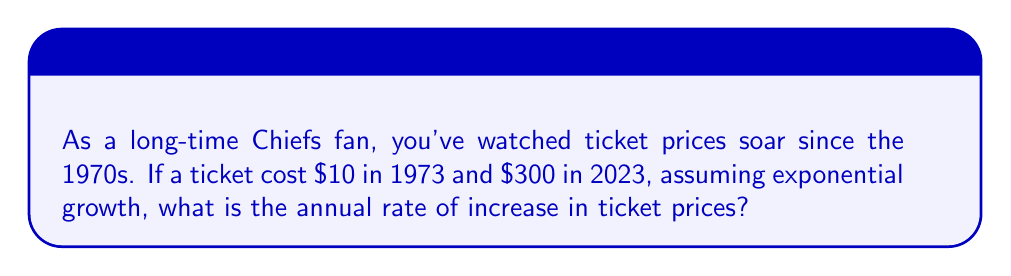Could you help me with this problem? Let's approach this step-by-step using exponential modeling:

1) The exponential growth model is given by:
   $$P(t) = P_0 \cdot (1+r)^t$$
   where $P(t)$ is the price after $t$ years, $P_0$ is the initial price, and $r$ is the annual rate of increase.

2) We know:
   $P_0 = \$10$ (initial price in 1973)
   $P(50) = \$300$ (price after 50 years, in 2023)
   $t = 50$ years

3) Plugging these into our equation:
   $$300 = 10 \cdot (1+r)^{50}$$

4) Divide both sides by 10:
   $$30 = (1+r)^{50}$$

5) Take the 50th root of both sides:
   $$\sqrt[50]{30} = 1+r$$

6) Subtract 1 from both sides:
   $$\sqrt[50]{30} - 1 = r$$

7) Calculate:
   $$r \approx 1.0718 - 1 = 0.0718$$

8) Convert to percentage:
   $$r \approx 7.18\%$$

Therefore, the annual rate of increase in ticket prices is approximately 7.18%.
Answer: 7.18% 